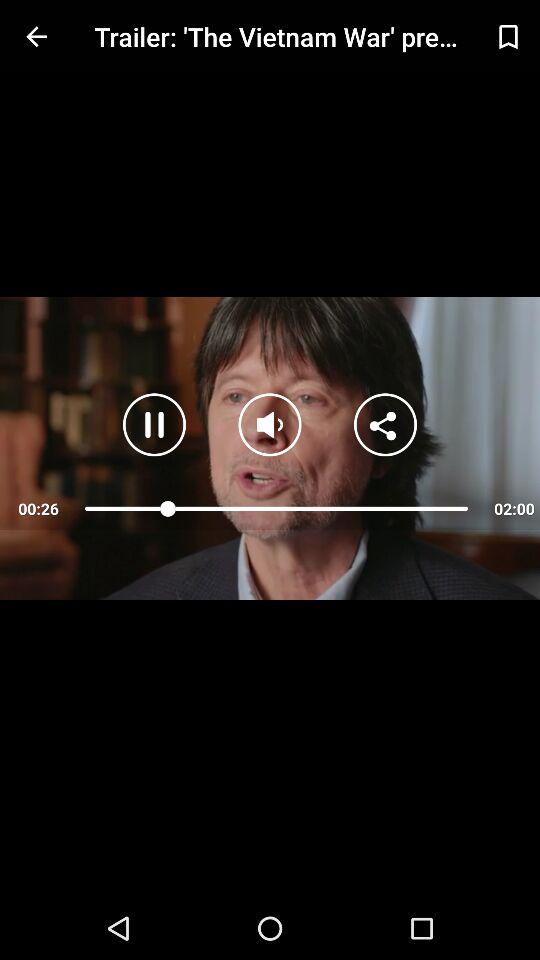What is the time elapsed for "The Vietnam War" trailer video? The time elapsed is 26 seconds. 